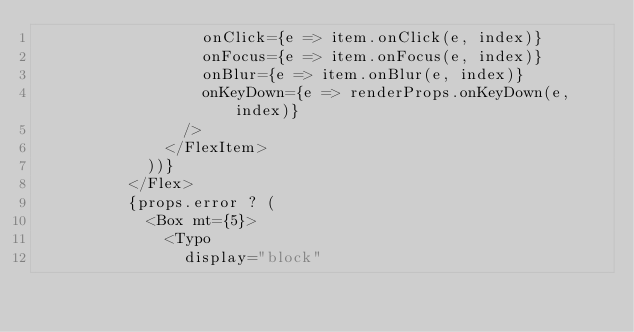Convert code to text. <code><loc_0><loc_0><loc_500><loc_500><_TypeScript_>                  onClick={e => item.onClick(e, index)}
                  onFocus={e => item.onFocus(e, index)}
                  onBlur={e => item.onBlur(e, index)}
                  onKeyDown={e => renderProps.onKeyDown(e, index)}
                />
              </FlexItem>
            ))}
          </Flex>
          {props.error ? (
            <Box mt={5}>
              <Typo
                display="block"</code> 